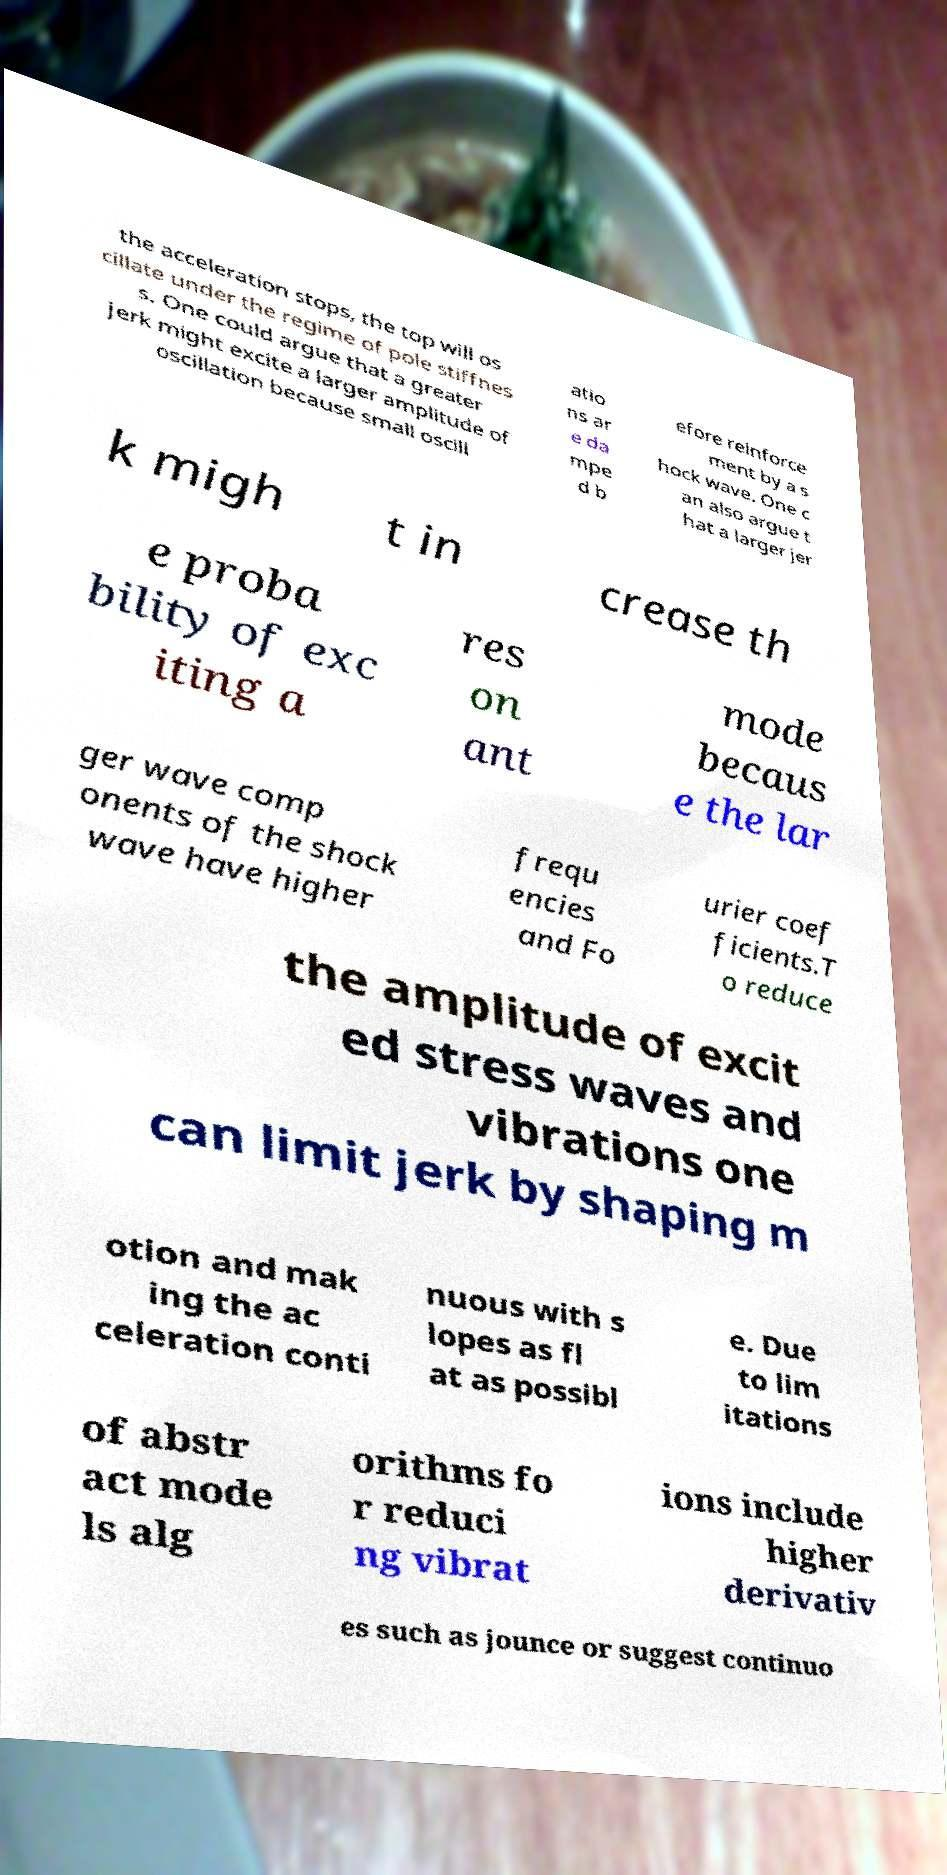Please read and relay the text visible in this image. What does it say? the acceleration stops, the top will os cillate under the regime of pole stiffnes s. One could argue that a greater jerk might excite a larger amplitude of oscillation because small oscill atio ns ar e da mpe d b efore reinforce ment by a s hock wave. One c an also argue t hat a larger jer k migh t in crease th e proba bility of exc iting a res on ant mode becaus e the lar ger wave comp onents of the shock wave have higher frequ encies and Fo urier coef ficients.T o reduce the amplitude of excit ed stress waves and vibrations one can limit jerk by shaping m otion and mak ing the ac celeration conti nuous with s lopes as fl at as possibl e. Due to lim itations of abstr act mode ls alg orithms fo r reduci ng vibrat ions include higher derivativ es such as jounce or suggest continuo 